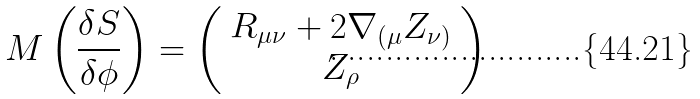Convert formula to latex. <formula><loc_0><loc_0><loc_500><loc_500>M \left ( \frac { \delta S } { \delta \phi } \right ) = \left ( \begin{array} { c } R _ { \mu \nu } + 2 \nabla _ { ( \mu } Z _ { \nu ) } \\ Z _ { \rho } \end{array} \right )</formula> 